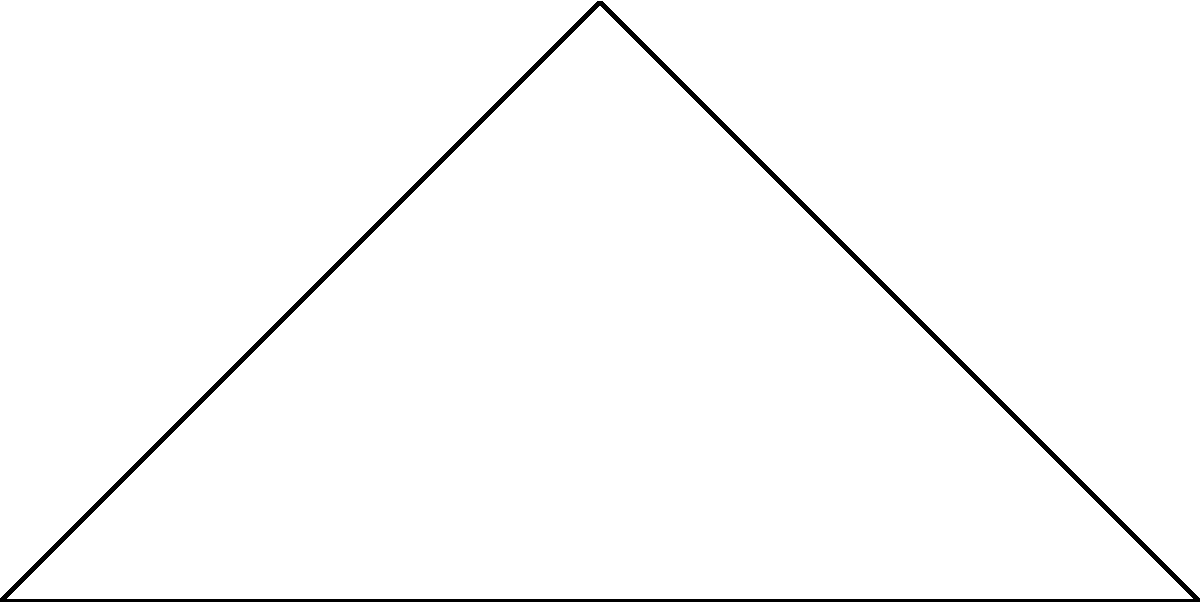In a suburban neighborhood, you're tasked with calculating the height of a newly constructed house. The roof forms a perfect triangle, with a base width of 15 meters and a roof angle of 30°. Using your knowledge of trigonometry, determine the height of the house from the base to the peak of the roof. Round your answer to the nearest tenth of a meter. Let's approach this step-by-step:

1) In the diagram, we have a right triangle where:
   - The base (AB) is 15 meters
   - The angle at the peak (C) is 30°
   - We need to find the height (h)

2) We can split this isosceles triangle into two right triangles. Let's focus on one of them.

3) In this right triangle:
   - The base is half of the total width: 15/2 = 7.5 meters
   - The angle opposite to the height is 30°
   - We need to find the opposite side (height)

4) This is a perfect scenario to use the tangent function:

   $$\tan(30°) = \frac{\text{opposite}}{\text{adjacent}} = \frac{h}{7.5}$$

5) We know that $\tan(30°) = \frac{1}{\sqrt{3}}$, so:

   $$\frac{1}{\sqrt{3}} = \frac{h}{7.5}$$

6) Cross multiply:

   $$h = 7.5 \cdot \frac{1}{\sqrt{3}} = \frac{7.5}{\sqrt{3}}$$

7) Simplify:
   
   $$h = \frac{7.5}{\sqrt{3}} \approx 4.33$$

8) Rounding to the nearest tenth:

   $$h \approx 4.3 \text{ meters}$$

Thus, the height of the house from the base to the peak of the roof is approximately 4.3 meters.
Answer: 4.3 meters 